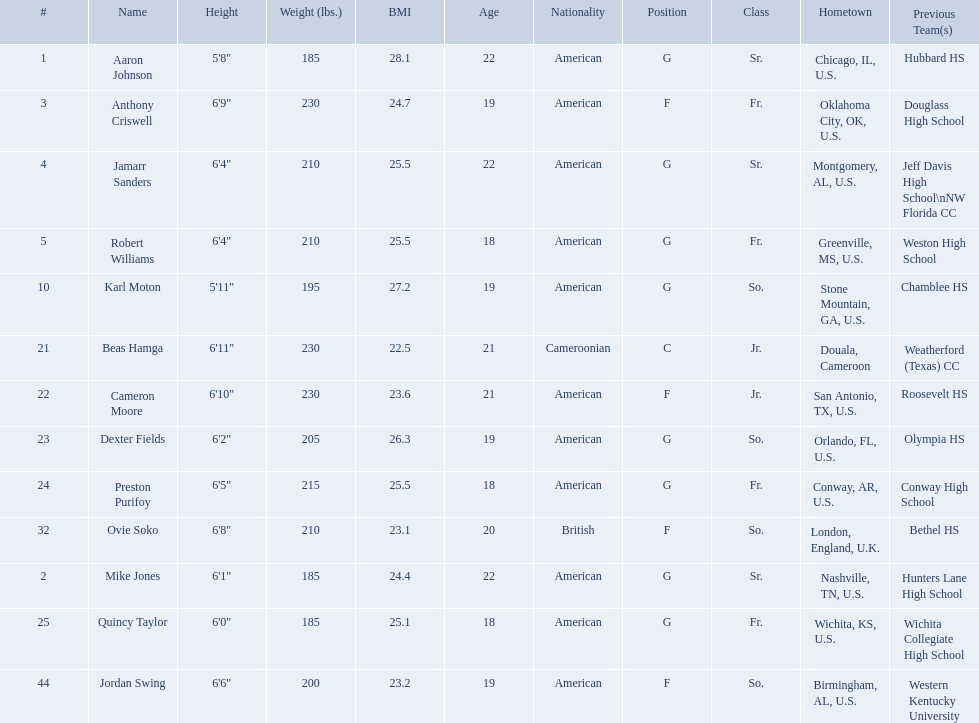Which are all of the players? Aaron Johnson, Anthony Criswell, Jamarr Sanders, Robert Williams, Karl Moton, Beas Hamga, Cameron Moore, Dexter Fields, Preston Purifoy, Ovie Soko, Mike Jones, Quincy Taylor, Jordan Swing. Which players are from a country outside of the u.s.? Beas Hamga, Ovie Soko. Aside from soko, who else is not from the u.s.? Beas Hamga. 